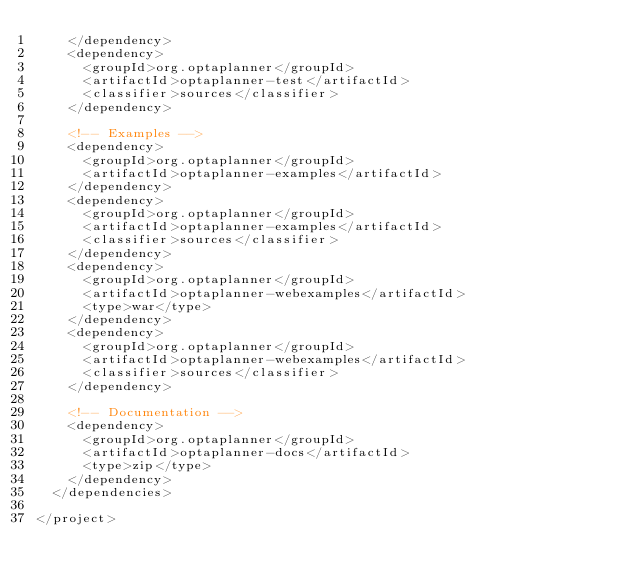<code> <loc_0><loc_0><loc_500><loc_500><_XML_>    </dependency>
    <dependency>
      <groupId>org.optaplanner</groupId>
      <artifactId>optaplanner-test</artifactId>
      <classifier>sources</classifier>
    </dependency>

    <!-- Examples -->
    <dependency>
      <groupId>org.optaplanner</groupId>
      <artifactId>optaplanner-examples</artifactId>
    </dependency>
    <dependency>
      <groupId>org.optaplanner</groupId>
      <artifactId>optaplanner-examples</artifactId>
      <classifier>sources</classifier>
    </dependency>
    <dependency>
      <groupId>org.optaplanner</groupId>
      <artifactId>optaplanner-webexamples</artifactId>
      <type>war</type>
    </dependency>
    <dependency>
      <groupId>org.optaplanner</groupId>
      <artifactId>optaplanner-webexamples</artifactId>
      <classifier>sources</classifier>
    </dependency>

    <!-- Documentation -->
    <dependency>
      <groupId>org.optaplanner</groupId>
      <artifactId>optaplanner-docs</artifactId>
      <type>zip</type>
    </dependency>
  </dependencies>

</project>
</code> 